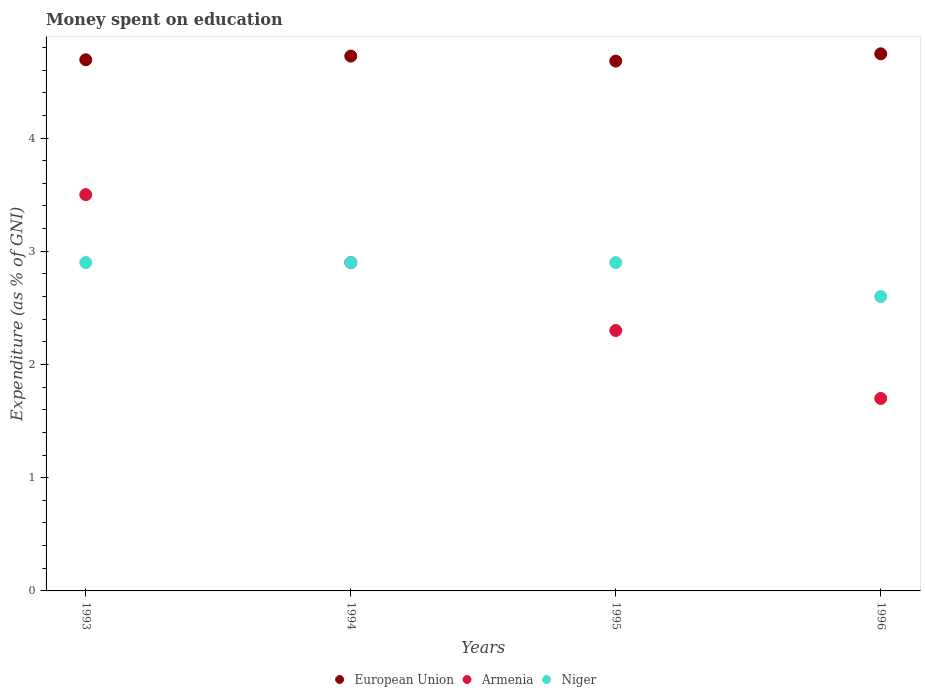What is the amount of money spent on education in Armenia in 1994?
Your answer should be compact. 2.9. Across all years, what is the maximum amount of money spent on education in European Union?
Offer a very short reply. 4.74. What is the total amount of money spent on education in European Union in the graph?
Your answer should be compact. 18.84. What is the difference between the amount of money spent on education in Armenia in 1994 and that in 1995?
Your response must be concise. 0.6. What is the difference between the amount of money spent on education in Armenia in 1993 and the amount of money spent on education in Niger in 1996?
Provide a short and direct response. 0.9. What is the average amount of money spent on education in European Union per year?
Provide a succinct answer. 4.71. In the year 1994, what is the difference between the amount of money spent on education in European Union and amount of money spent on education in Niger?
Make the answer very short. 1.82. In how many years, is the amount of money spent on education in European Union greater than 0.6000000000000001 %?
Offer a very short reply. 4. What is the ratio of the amount of money spent on education in Niger in 1995 to that in 1996?
Give a very brief answer. 1.12. Is the amount of money spent on education in European Union in 1994 less than that in 1995?
Your answer should be compact. No. Is the difference between the amount of money spent on education in European Union in 1993 and 1994 greater than the difference between the amount of money spent on education in Niger in 1993 and 1994?
Your answer should be compact. No. What is the difference between the highest and the second highest amount of money spent on education in Armenia?
Give a very brief answer. 0.6. What is the difference between the highest and the lowest amount of money spent on education in Niger?
Ensure brevity in your answer.  0.3. Is the sum of the amount of money spent on education in Niger in 1993 and 1996 greater than the maximum amount of money spent on education in European Union across all years?
Give a very brief answer. Yes. Is the amount of money spent on education in Niger strictly greater than the amount of money spent on education in Armenia over the years?
Give a very brief answer. No. Is the amount of money spent on education in Niger strictly less than the amount of money spent on education in Armenia over the years?
Provide a short and direct response. No. What is the difference between two consecutive major ticks on the Y-axis?
Give a very brief answer. 1. Does the graph contain grids?
Make the answer very short. No. How are the legend labels stacked?
Your answer should be compact. Horizontal. What is the title of the graph?
Keep it short and to the point. Money spent on education. Does "Morocco" appear as one of the legend labels in the graph?
Make the answer very short. No. What is the label or title of the X-axis?
Give a very brief answer. Years. What is the label or title of the Y-axis?
Make the answer very short. Expenditure (as % of GNI). What is the Expenditure (as % of GNI) of European Union in 1993?
Make the answer very short. 4.69. What is the Expenditure (as % of GNI) of Niger in 1993?
Keep it short and to the point. 2.9. What is the Expenditure (as % of GNI) in European Union in 1994?
Your answer should be compact. 4.72. What is the Expenditure (as % of GNI) in Armenia in 1994?
Provide a succinct answer. 2.9. What is the Expenditure (as % of GNI) in Niger in 1994?
Offer a terse response. 2.9. What is the Expenditure (as % of GNI) in European Union in 1995?
Provide a short and direct response. 4.68. What is the Expenditure (as % of GNI) in Armenia in 1995?
Your response must be concise. 2.3. What is the Expenditure (as % of GNI) of European Union in 1996?
Your answer should be very brief. 4.74. Across all years, what is the maximum Expenditure (as % of GNI) in European Union?
Your answer should be very brief. 4.74. Across all years, what is the maximum Expenditure (as % of GNI) in Armenia?
Make the answer very short. 3.5. Across all years, what is the maximum Expenditure (as % of GNI) in Niger?
Give a very brief answer. 2.9. Across all years, what is the minimum Expenditure (as % of GNI) of European Union?
Offer a terse response. 4.68. Across all years, what is the minimum Expenditure (as % of GNI) of Armenia?
Your response must be concise. 1.7. Across all years, what is the minimum Expenditure (as % of GNI) in Niger?
Offer a very short reply. 2.6. What is the total Expenditure (as % of GNI) of European Union in the graph?
Your answer should be compact. 18.84. What is the total Expenditure (as % of GNI) in Armenia in the graph?
Provide a succinct answer. 10.4. What is the difference between the Expenditure (as % of GNI) in European Union in 1993 and that in 1994?
Make the answer very short. -0.03. What is the difference between the Expenditure (as % of GNI) of European Union in 1993 and that in 1995?
Make the answer very short. 0.01. What is the difference between the Expenditure (as % of GNI) of Armenia in 1993 and that in 1995?
Your response must be concise. 1.2. What is the difference between the Expenditure (as % of GNI) in European Union in 1993 and that in 1996?
Your answer should be very brief. -0.05. What is the difference between the Expenditure (as % of GNI) of European Union in 1994 and that in 1995?
Offer a terse response. 0.04. What is the difference between the Expenditure (as % of GNI) in Niger in 1994 and that in 1995?
Give a very brief answer. 0. What is the difference between the Expenditure (as % of GNI) of European Union in 1994 and that in 1996?
Make the answer very short. -0.02. What is the difference between the Expenditure (as % of GNI) in Niger in 1994 and that in 1996?
Provide a succinct answer. 0.3. What is the difference between the Expenditure (as % of GNI) in European Union in 1995 and that in 1996?
Provide a short and direct response. -0.06. What is the difference between the Expenditure (as % of GNI) of Armenia in 1995 and that in 1996?
Your answer should be compact. 0.6. What is the difference between the Expenditure (as % of GNI) of Niger in 1995 and that in 1996?
Your answer should be compact. 0.3. What is the difference between the Expenditure (as % of GNI) in European Union in 1993 and the Expenditure (as % of GNI) in Armenia in 1994?
Your answer should be very brief. 1.79. What is the difference between the Expenditure (as % of GNI) in European Union in 1993 and the Expenditure (as % of GNI) in Niger in 1994?
Your answer should be very brief. 1.79. What is the difference between the Expenditure (as % of GNI) of Armenia in 1993 and the Expenditure (as % of GNI) of Niger in 1994?
Provide a short and direct response. 0.6. What is the difference between the Expenditure (as % of GNI) of European Union in 1993 and the Expenditure (as % of GNI) of Armenia in 1995?
Provide a short and direct response. 2.39. What is the difference between the Expenditure (as % of GNI) in European Union in 1993 and the Expenditure (as % of GNI) in Niger in 1995?
Provide a short and direct response. 1.79. What is the difference between the Expenditure (as % of GNI) in Armenia in 1993 and the Expenditure (as % of GNI) in Niger in 1995?
Your answer should be compact. 0.6. What is the difference between the Expenditure (as % of GNI) of European Union in 1993 and the Expenditure (as % of GNI) of Armenia in 1996?
Your answer should be compact. 2.99. What is the difference between the Expenditure (as % of GNI) in European Union in 1993 and the Expenditure (as % of GNI) in Niger in 1996?
Your answer should be compact. 2.09. What is the difference between the Expenditure (as % of GNI) in Armenia in 1993 and the Expenditure (as % of GNI) in Niger in 1996?
Keep it short and to the point. 0.9. What is the difference between the Expenditure (as % of GNI) in European Union in 1994 and the Expenditure (as % of GNI) in Armenia in 1995?
Your response must be concise. 2.42. What is the difference between the Expenditure (as % of GNI) of European Union in 1994 and the Expenditure (as % of GNI) of Niger in 1995?
Provide a succinct answer. 1.82. What is the difference between the Expenditure (as % of GNI) in Armenia in 1994 and the Expenditure (as % of GNI) in Niger in 1995?
Keep it short and to the point. -0. What is the difference between the Expenditure (as % of GNI) in European Union in 1994 and the Expenditure (as % of GNI) in Armenia in 1996?
Your answer should be compact. 3.02. What is the difference between the Expenditure (as % of GNI) in European Union in 1994 and the Expenditure (as % of GNI) in Niger in 1996?
Keep it short and to the point. 2.12. What is the difference between the Expenditure (as % of GNI) in European Union in 1995 and the Expenditure (as % of GNI) in Armenia in 1996?
Make the answer very short. 2.98. What is the difference between the Expenditure (as % of GNI) of European Union in 1995 and the Expenditure (as % of GNI) of Niger in 1996?
Offer a terse response. 2.08. What is the difference between the Expenditure (as % of GNI) of Armenia in 1995 and the Expenditure (as % of GNI) of Niger in 1996?
Your response must be concise. -0.3. What is the average Expenditure (as % of GNI) of European Union per year?
Offer a terse response. 4.71. What is the average Expenditure (as % of GNI) of Niger per year?
Make the answer very short. 2.83. In the year 1993, what is the difference between the Expenditure (as % of GNI) of European Union and Expenditure (as % of GNI) of Armenia?
Offer a very short reply. 1.19. In the year 1993, what is the difference between the Expenditure (as % of GNI) in European Union and Expenditure (as % of GNI) in Niger?
Your answer should be compact. 1.79. In the year 1994, what is the difference between the Expenditure (as % of GNI) of European Union and Expenditure (as % of GNI) of Armenia?
Keep it short and to the point. 1.82. In the year 1994, what is the difference between the Expenditure (as % of GNI) in European Union and Expenditure (as % of GNI) in Niger?
Your answer should be compact. 1.82. In the year 1994, what is the difference between the Expenditure (as % of GNI) in Armenia and Expenditure (as % of GNI) in Niger?
Provide a short and direct response. -0. In the year 1995, what is the difference between the Expenditure (as % of GNI) of European Union and Expenditure (as % of GNI) of Armenia?
Provide a succinct answer. 2.38. In the year 1995, what is the difference between the Expenditure (as % of GNI) of European Union and Expenditure (as % of GNI) of Niger?
Your answer should be compact. 1.78. In the year 1996, what is the difference between the Expenditure (as % of GNI) in European Union and Expenditure (as % of GNI) in Armenia?
Provide a succinct answer. 3.04. In the year 1996, what is the difference between the Expenditure (as % of GNI) in European Union and Expenditure (as % of GNI) in Niger?
Your answer should be very brief. 2.14. What is the ratio of the Expenditure (as % of GNI) of Armenia in 1993 to that in 1994?
Provide a short and direct response. 1.21. What is the ratio of the Expenditure (as % of GNI) in Niger in 1993 to that in 1994?
Provide a short and direct response. 1. What is the ratio of the Expenditure (as % of GNI) of Armenia in 1993 to that in 1995?
Ensure brevity in your answer.  1.52. What is the ratio of the Expenditure (as % of GNI) of Niger in 1993 to that in 1995?
Make the answer very short. 1. What is the ratio of the Expenditure (as % of GNI) of European Union in 1993 to that in 1996?
Offer a very short reply. 0.99. What is the ratio of the Expenditure (as % of GNI) of Armenia in 1993 to that in 1996?
Give a very brief answer. 2.06. What is the ratio of the Expenditure (as % of GNI) in Niger in 1993 to that in 1996?
Provide a succinct answer. 1.12. What is the ratio of the Expenditure (as % of GNI) in European Union in 1994 to that in 1995?
Your response must be concise. 1.01. What is the ratio of the Expenditure (as % of GNI) in Armenia in 1994 to that in 1995?
Offer a terse response. 1.26. What is the ratio of the Expenditure (as % of GNI) of Niger in 1994 to that in 1995?
Provide a short and direct response. 1. What is the ratio of the Expenditure (as % of GNI) of European Union in 1994 to that in 1996?
Provide a succinct answer. 1. What is the ratio of the Expenditure (as % of GNI) of Armenia in 1994 to that in 1996?
Keep it short and to the point. 1.71. What is the ratio of the Expenditure (as % of GNI) of Niger in 1994 to that in 1996?
Ensure brevity in your answer.  1.12. What is the ratio of the Expenditure (as % of GNI) of European Union in 1995 to that in 1996?
Your answer should be very brief. 0.99. What is the ratio of the Expenditure (as % of GNI) of Armenia in 1995 to that in 1996?
Ensure brevity in your answer.  1.35. What is the ratio of the Expenditure (as % of GNI) of Niger in 1995 to that in 1996?
Make the answer very short. 1.12. What is the difference between the highest and the second highest Expenditure (as % of GNI) in European Union?
Provide a short and direct response. 0.02. What is the difference between the highest and the second highest Expenditure (as % of GNI) of Niger?
Offer a very short reply. 0. What is the difference between the highest and the lowest Expenditure (as % of GNI) in European Union?
Offer a terse response. 0.06. What is the difference between the highest and the lowest Expenditure (as % of GNI) in Armenia?
Keep it short and to the point. 1.8. What is the difference between the highest and the lowest Expenditure (as % of GNI) of Niger?
Keep it short and to the point. 0.3. 